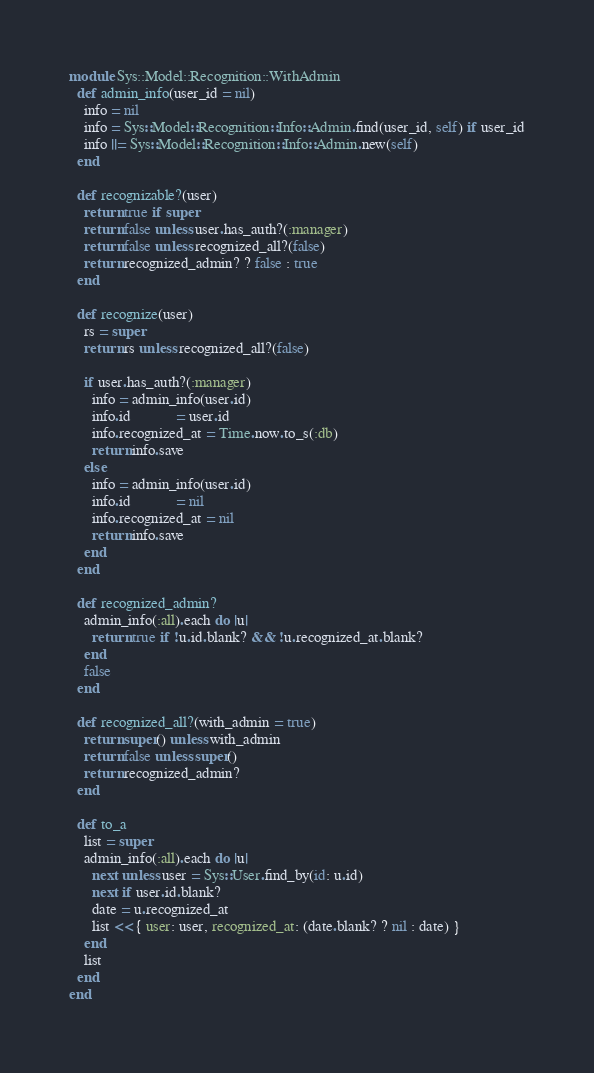Convert code to text. <code><loc_0><loc_0><loc_500><loc_500><_Ruby_>module Sys::Model::Recognition::WithAdmin
  def admin_info(user_id = nil)
    info = nil
    info = Sys::Model::Recognition::Info::Admin.find(user_id, self) if user_id
    info ||= Sys::Model::Recognition::Info::Admin.new(self)
  end
  
  def recognizable?(user)
    return true if super
    return false unless user.has_auth?(:manager)
    return false unless recognized_all?(false)
    return recognized_admin? ? false : true
  end
  
  def recognize(user)
    rs = super
    return rs unless recognized_all?(false)
    
    if user.has_auth?(:manager)
      info = admin_info(user.id)
      info.id            = user.id
      info.recognized_at = Time.now.to_s(:db)
      return info.save
    else
      info = admin_info(user.id)
      info.id            = nil
      info.recognized_at = nil
      return info.save
    end
  end
  
  def recognized_admin?
    admin_info(:all).each do |u|
      return true if !u.id.blank? && !u.recognized_at.blank?
    end
    false
  end
  
  def recognized_all?(with_admin = true)
    return super() unless with_admin
    return false unless super()
    return recognized_admin?
  end
  
  def to_a
    list = super
    admin_info(:all).each do |u|
      next unless user = Sys::User.find_by(id: u.id)
      next if user.id.blank?
      date = u.recognized_at
      list << { user: user, recognized_at: (date.blank? ? nil : date) }
    end
    list
  end
end</code> 